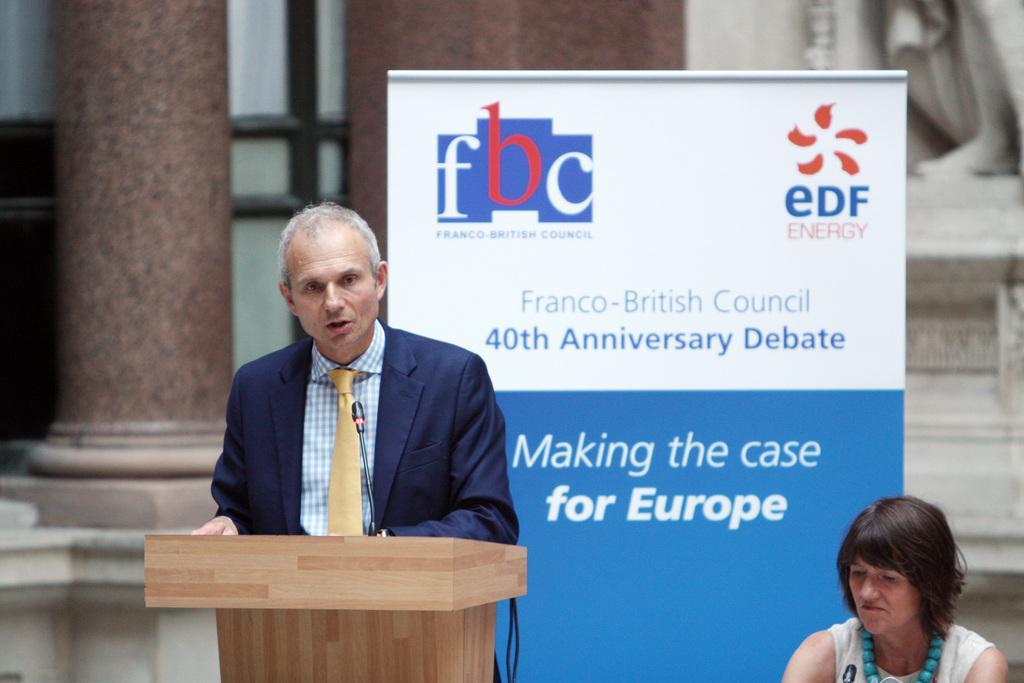Describe this image in one or two sentences. In the center of the image there is a person standing at a desk. On the right side of the image we can see a woman sitting. In the background there is a poster, pillar and wall. 